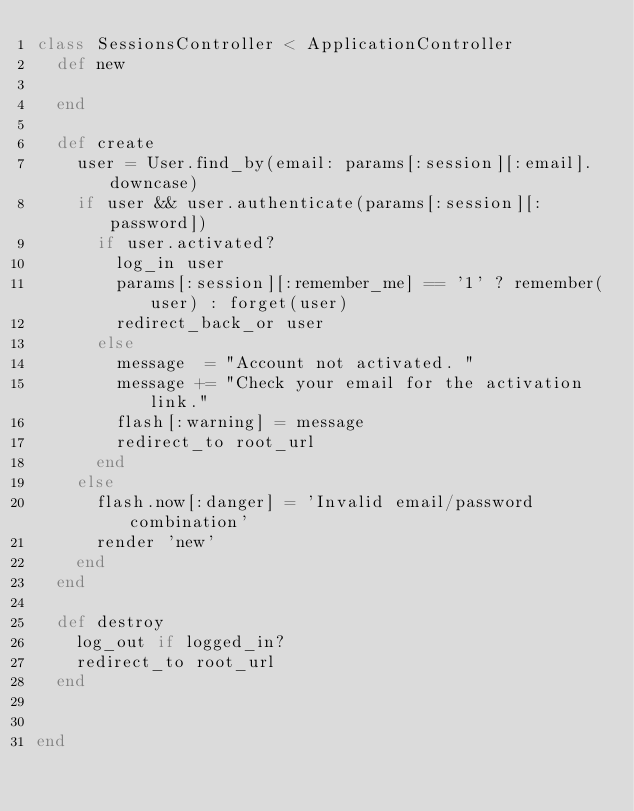<code> <loc_0><loc_0><loc_500><loc_500><_Ruby_>class SessionsController < ApplicationController
  def new
   
  end
  
  def create
    user = User.find_by(email: params[:session][:email].downcase)
    if user && user.authenticate(params[:session][:password])
      if user.activated?
        log_in user
        params[:session][:remember_me] == '1' ? remember(user) : forget(user)
        redirect_back_or user
      else
        message  = "Account not activated. "
        message += "Check your email for the activation link."
        flash[:warning] = message
        redirect_to root_url
      end
    else
      flash.now[:danger] = 'Invalid email/password combination'
      render 'new'
    end
  end

  def destroy
    log_out if logged_in?
    redirect_to root_url
  end  
  

end
</code> 